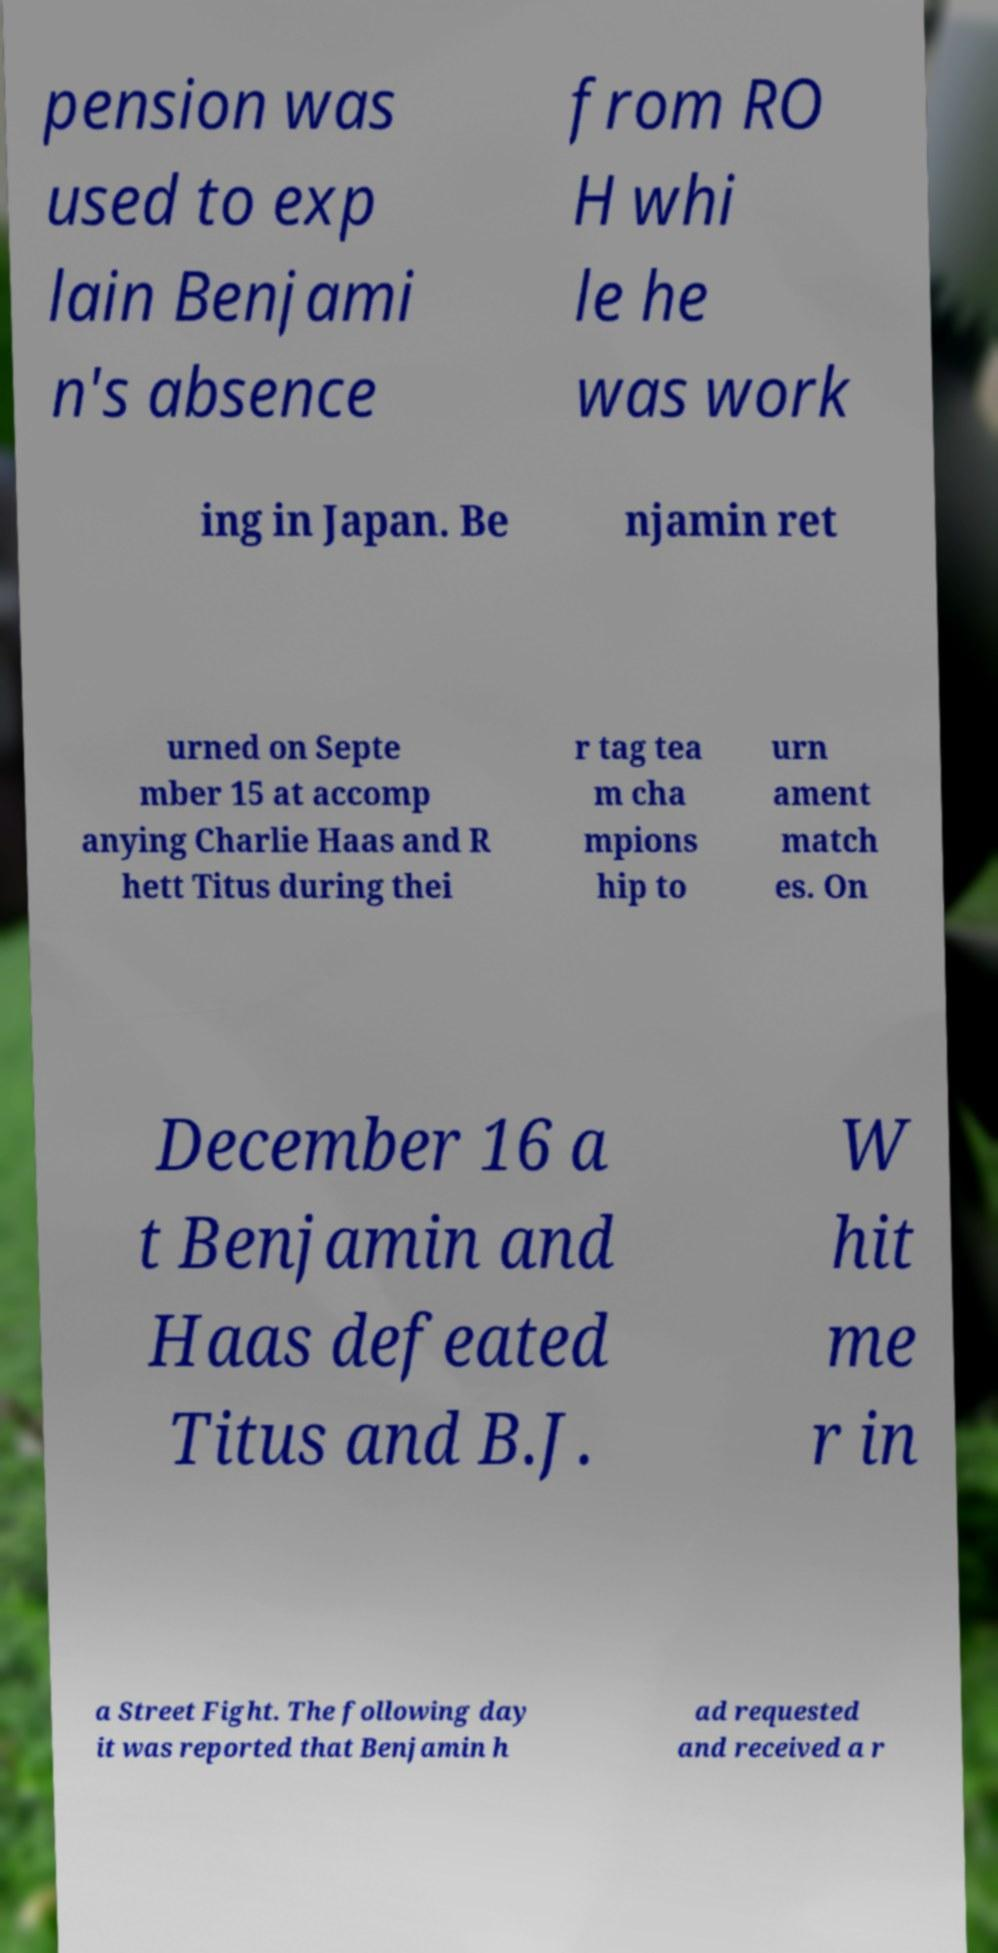What messages or text are displayed in this image? I need them in a readable, typed format. pension was used to exp lain Benjami n's absence from RO H whi le he was work ing in Japan. Be njamin ret urned on Septe mber 15 at accomp anying Charlie Haas and R hett Titus during thei r tag tea m cha mpions hip to urn ament match es. On December 16 a t Benjamin and Haas defeated Titus and B.J. W hit me r in a Street Fight. The following day it was reported that Benjamin h ad requested and received a r 